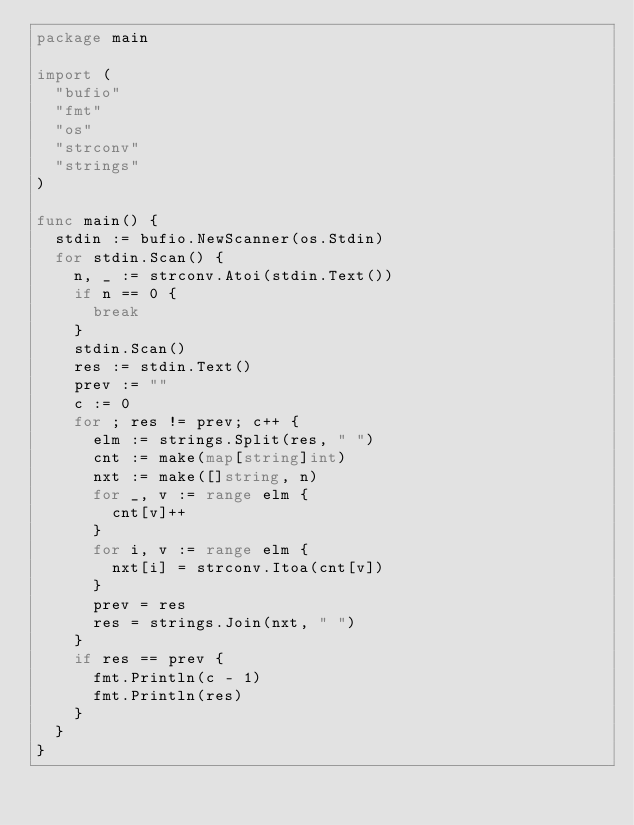<code> <loc_0><loc_0><loc_500><loc_500><_Go_>package main

import (
	"bufio"
	"fmt"
	"os"
	"strconv"
	"strings"
)

func main() {
	stdin := bufio.NewScanner(os.Stdin)
	for stdin.Scan() {
		n, _ := strconv.Atoi(stdin.Text())
		if n == 0 {
			break
		}
		stdin.Scan()
		res := stdin.Text()
		prev := ""
		c := 0
		for ; res != prev; c++ {
			elm := strings.Split(res, " ")
			cnt := make(map[string]int)
			nxt := make([]string, n)
			for _, v := range elm {
				cnt[v]++
			}
			for i, v := range elm {
				nxt[i] = strconv.Itoa(cnt[v])
			}
			prev = res
			res = strings.Join(nxt, " ")
		}
		if res == prev {
			fmt.Println(c - 1)
			fmt.Println(res)
		}
	}
}

</code> 